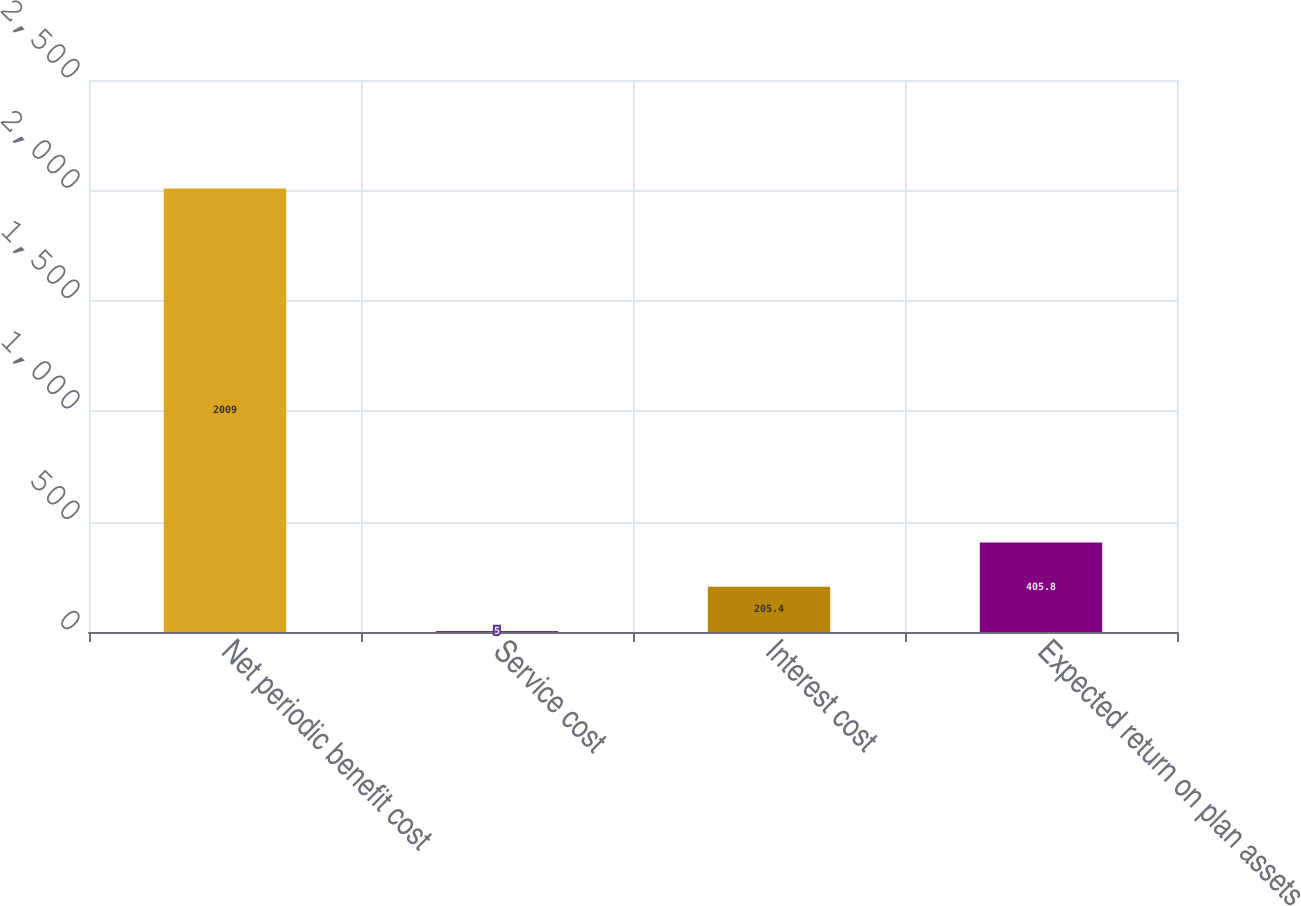<chart> <loc_0><loc_0><loc_500><loc_500><bar_chart><fcel>Net periodic benefit cost<fcel>Service cost<fcel>Interest cost<fcel>Expected return on plan assets<nl><fcel>2009<fcel>5<fcel>205.4<fcel>405.8<nl></chart> 